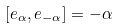<formula> <loc_0><loc_0><loc_500><loc_500>[ e _ { \alpha } , e _ { - \alpha } ] = - \alpha</formula> 